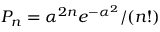<formula> <loc_0><loc_0><loc_500><loc_500>P _ { n } = \alpha ^ { 2 n } e ^ { - \alpha ^ { 2 } } / ( n ! )</formula> 